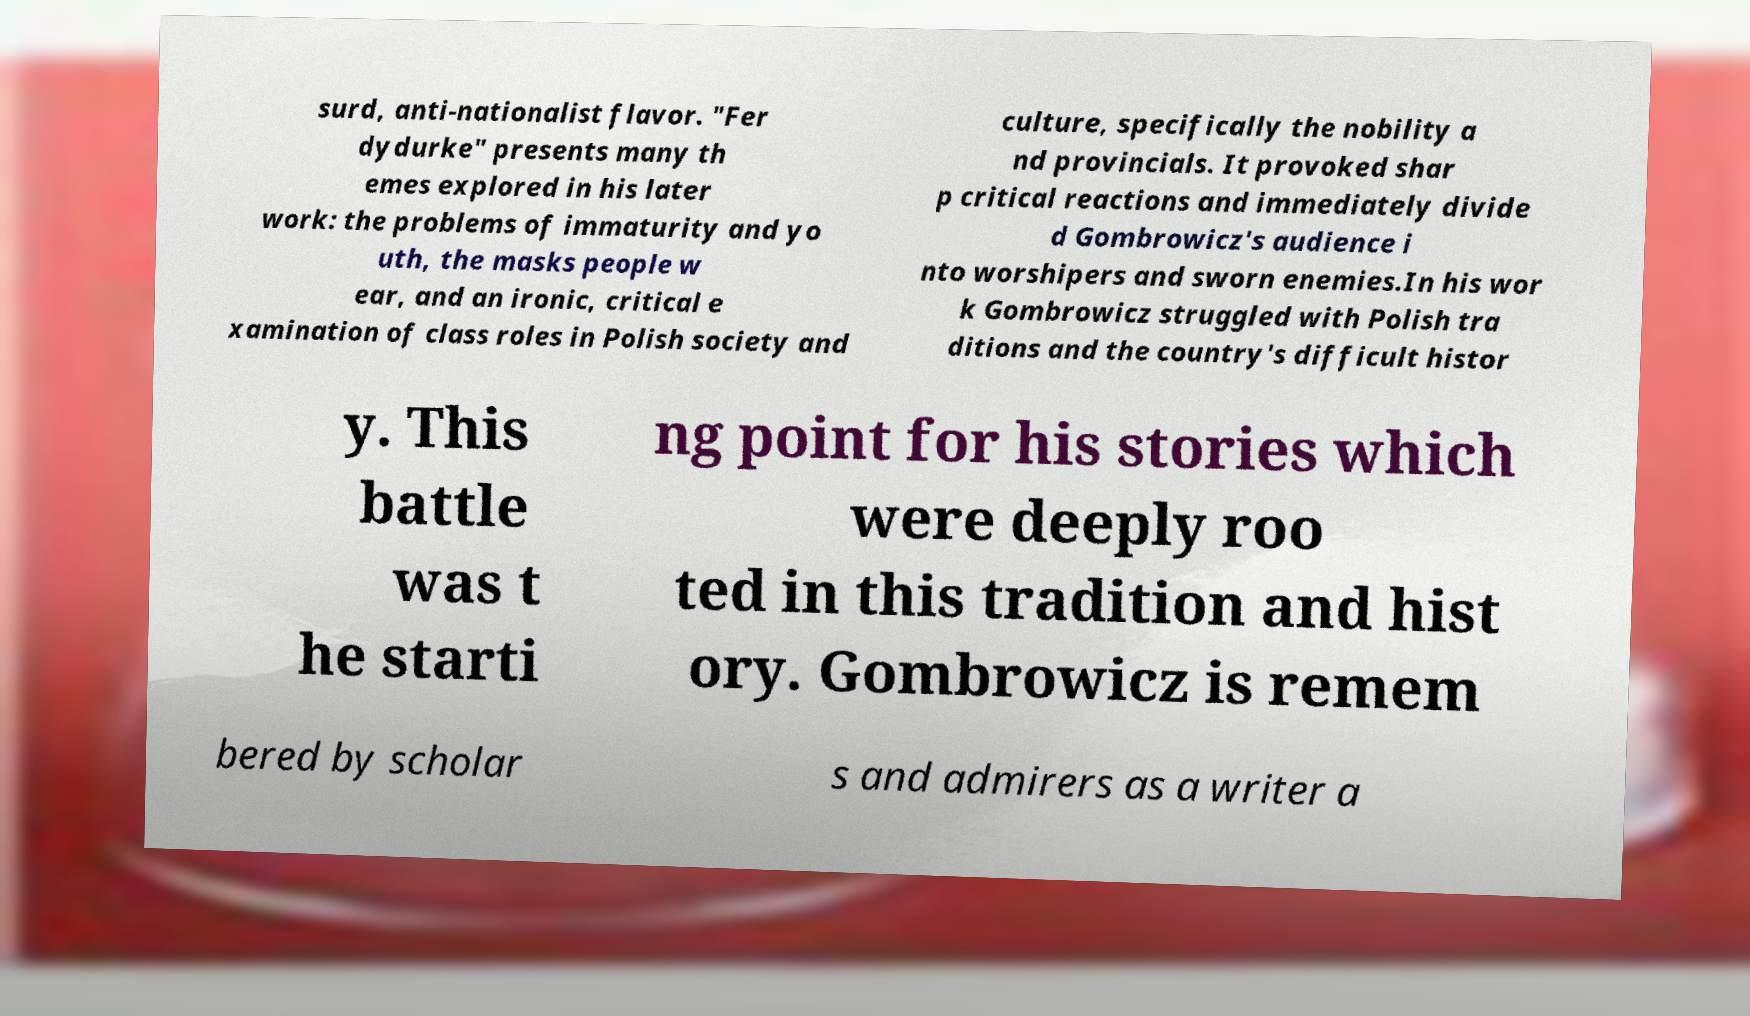Can you read and provide the text displayed in the image?This photo seems to have some interesting text. Can you extract and type it out for me? surd, anti-nationalist flavor. "Fer dydurke" presents many th emes explored in his later work: the problems of immaturity and yo uth, the masks people w ear, and an ironic, critical e xamination of class roles in Polish society and culture, specifically the nobility a nd provincials. It provoked shar p critical reactions and immediately divide d Gombrowicz's audience i nto worshipers and sworn enemies.In his wor k Gombrowicz struggled with Polish tra ditions and the country's difficult histor y. This battle was t he starti ng point for his stories which were deeply roo ted in this tradition and hist ory. Gombrowicz is remem bered by scholar s and admirers as a writer a 